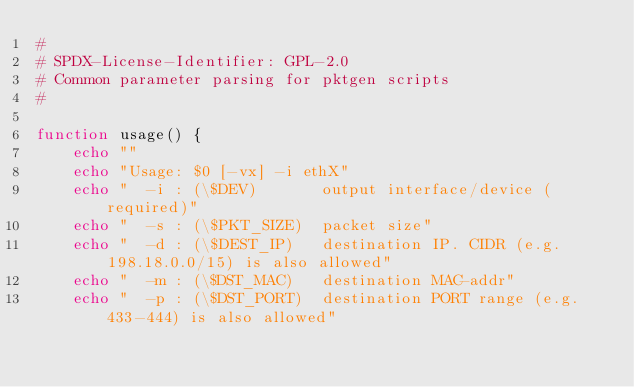<code> <loc_0><loc_0><loc_500><loc_500><_Bash_>#
# SPDX-License-Identifier: GPL-2.0
# Common parameter parsing for pktgen scripts
#

function usage() {
    echo ""
    echo "Usage: $0 [-vx] -i ethX"
    echo "  -i : (\$DEV)       output interface/device (required)"
    echo "  -s : (\$PKT_SIZE)  packet size"
    echo "  -d : (\$DEST_IP)   destination IP. CIDR (e.g. 198.18.0.0/15) is also allowed"
    echo "  -m : (\$DST_MAC)   destination MAC-addr"
    echo "  -p : (\$DST_PORT)  destination PORT range (e.g. 433-444) is also allowed"</code> 